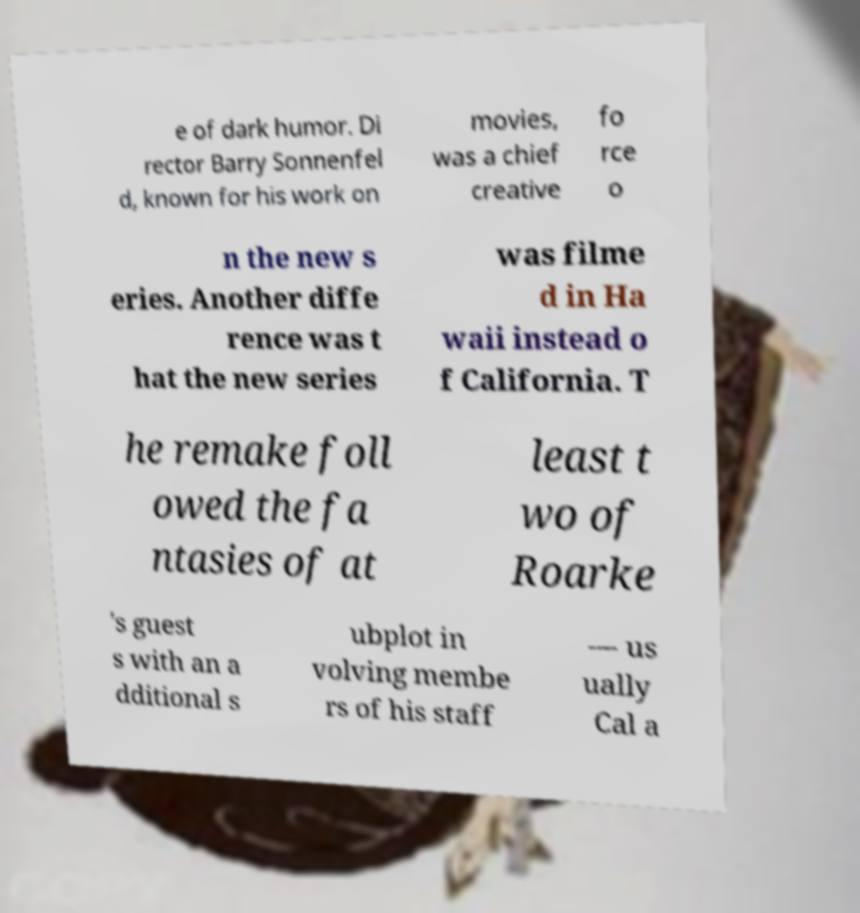Could you assist in decoding the text presented in this image and type it out clearly? e of dark humor. Di rector Barry Sonnenfel d, known for his work on movies, was a chief creative fo rce o n the new s eries. Another diffe rence was t hat the new series was filme d in Ha waii instead o f California. T he remake foll owed the fa ntasies of at least t wo of Roarke 's guest s with an a dditional s ubplot in volving membe rs of his staff — us ually Cal a 